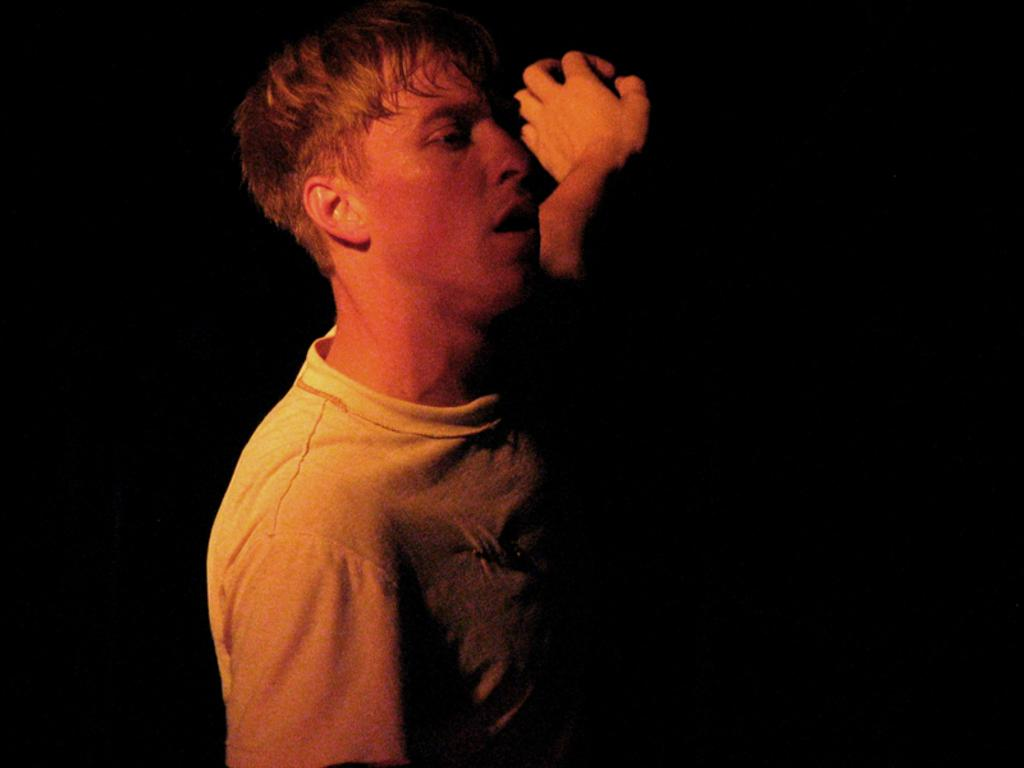Who is present in the image? There is a man in the image. What is the man wearing? The man is wearing clothes. What can be observed about the background of the image? The background of the image is dark. How many babies are visible in the image? There are no babies present in the image; it features a man. What type of whip is being used by the man in the image? There is no whip present in the image; the man is simply standing there. 